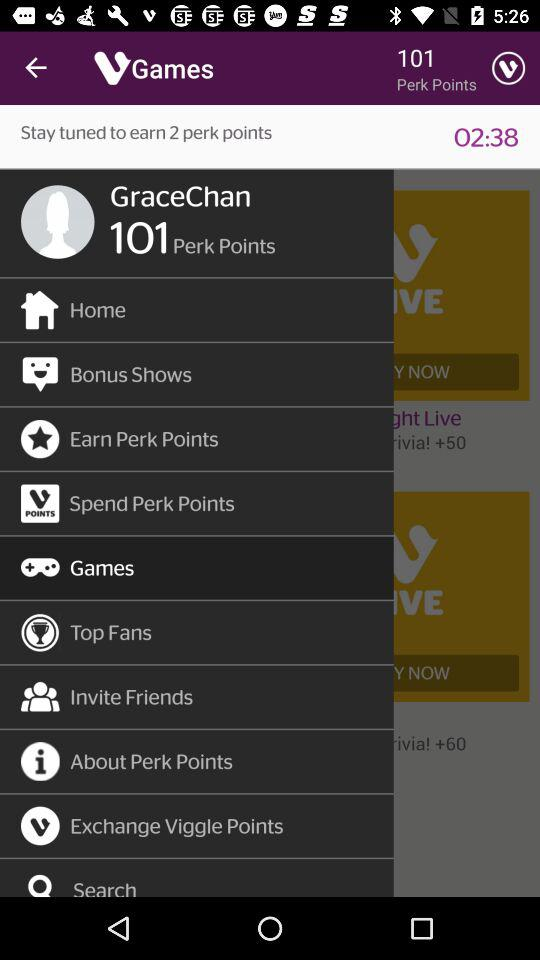Which is the selected item in the menu? The selected item is "Games". 